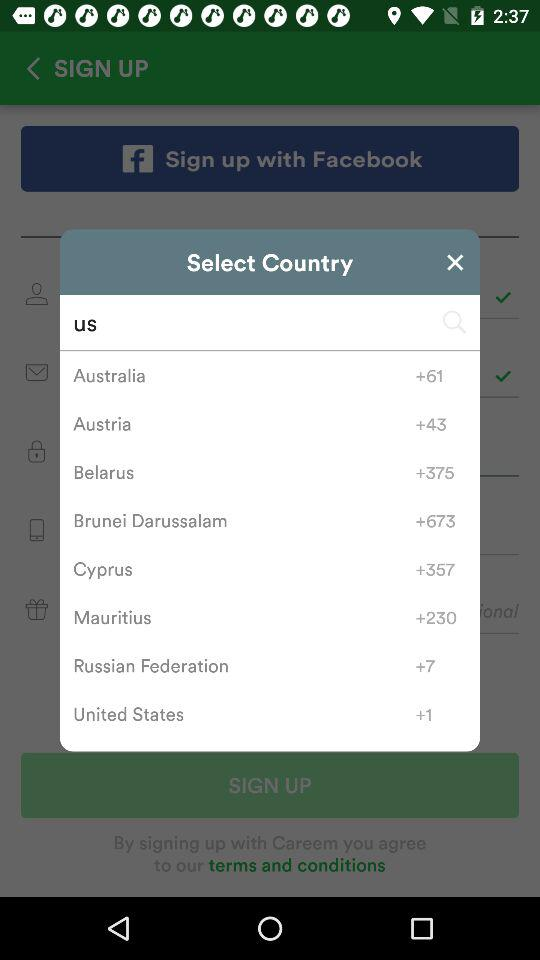What is the country code for Cyprus? The country code for Cyprus is +357. 